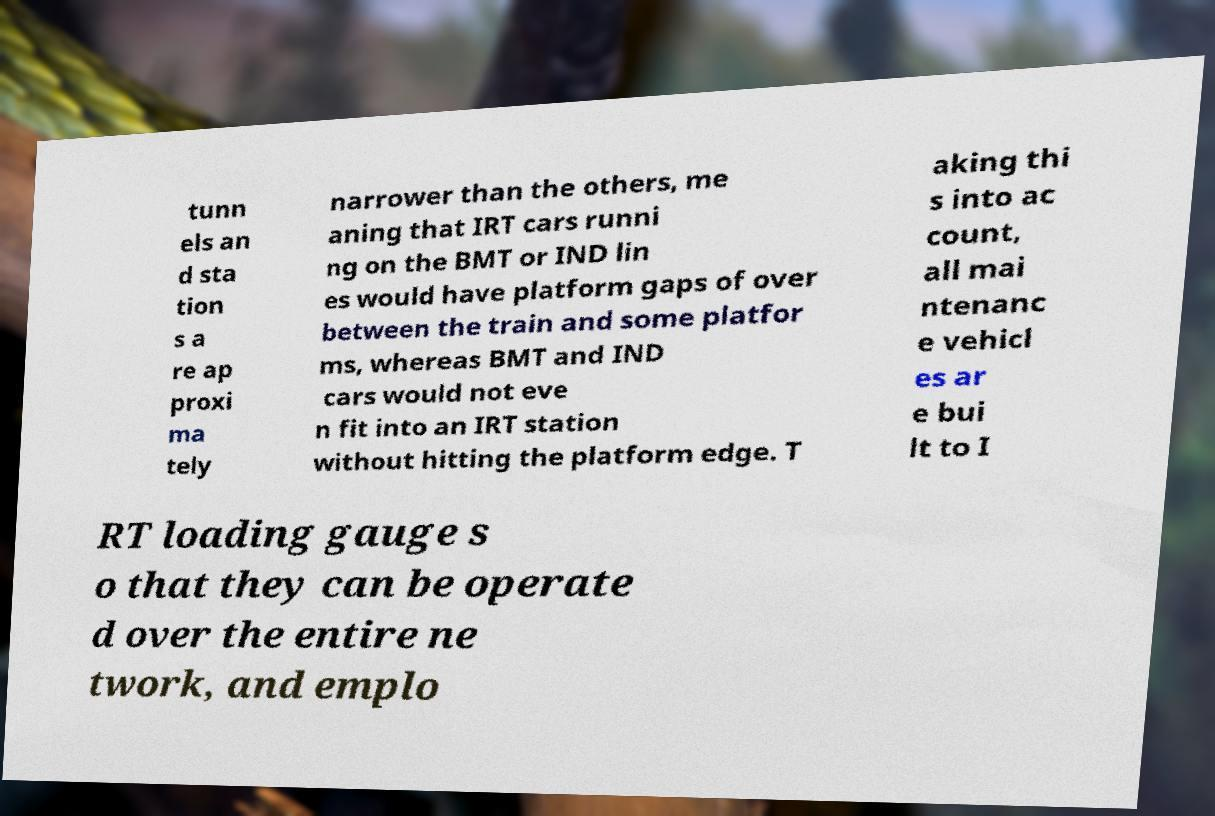There's text embedded in this image that I need extracted. Can you transcribe it verbatim? tunn els an d sta tion s a re ap proxi ma tely narrower than the others, me aning that IRT cars runni ng on the BMT or IND lin es would have platform gaps of over between the train and some platfor ms, whereas BMT and IND cars would not eve n fit into an IRT station without hitting the platform edge. T aking thi s into ac count, all mai ntenanc e vehicl es ar e bui lt to I RT loading gauge s o that they can be operate d over the entire ne twork, and emplo 